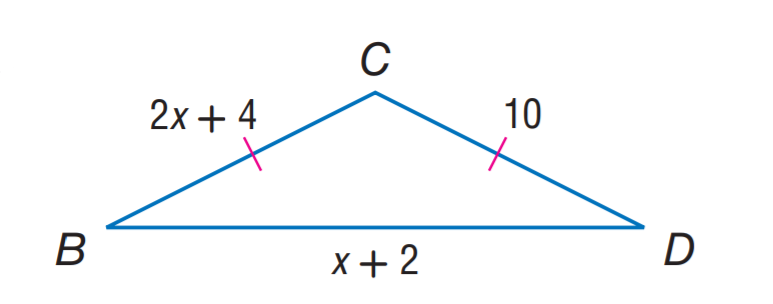Answer the mathemtical geometry problem and directly provide the correct option letter.
Question: Find B C.
Choices: A: 5 B: 8 C: 10 D: 12 C 